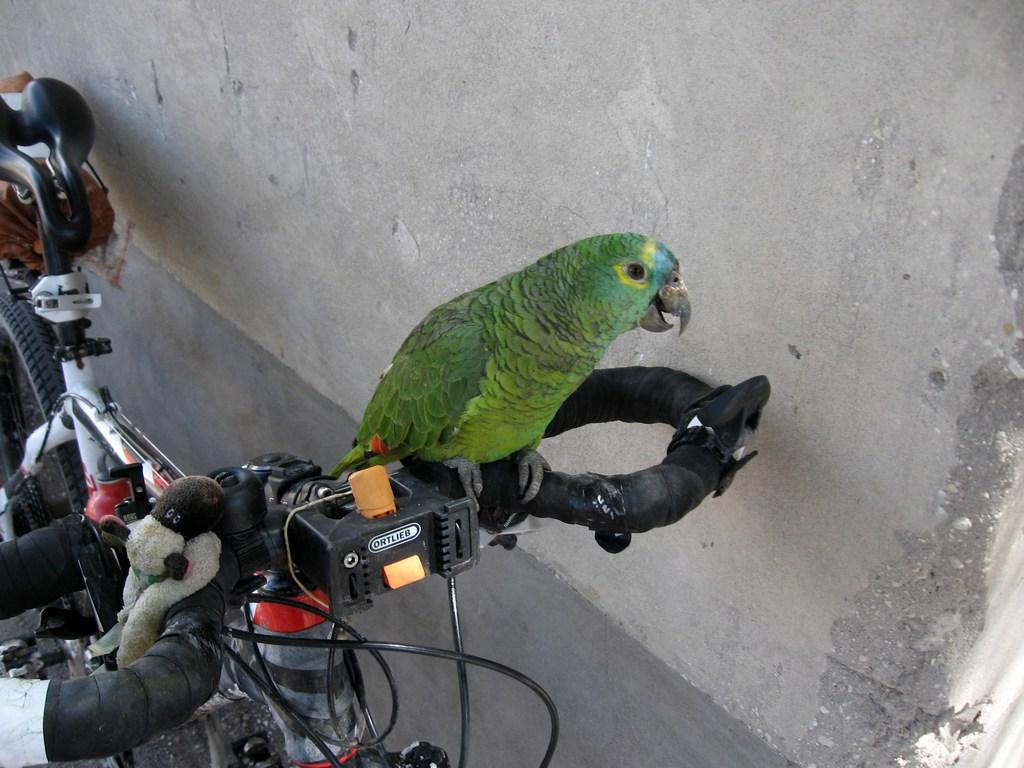What is the main object in the picture? There is a bicycle in the picture. What is sitting on the handle of the bicycle? A parrot is sitting on the handle of the bicycle. What color is the parrot? The parrot is green in color. Where is the bicycle located in relation to other objects? The bicycle is near a wall. What type of food is the parrot eating in the picture? There is no food present in the image, and the parrot is not eating anything. 